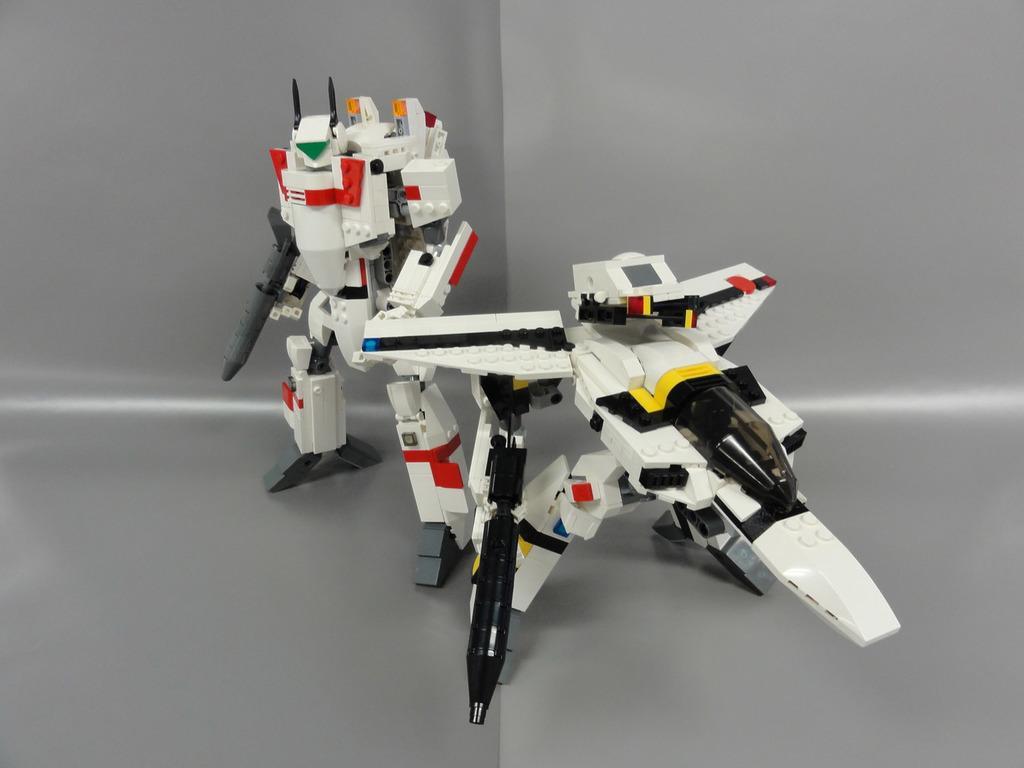Describe this image in one or two sentences. In this image I can see few toys in multicolor. Background is in grey color. 